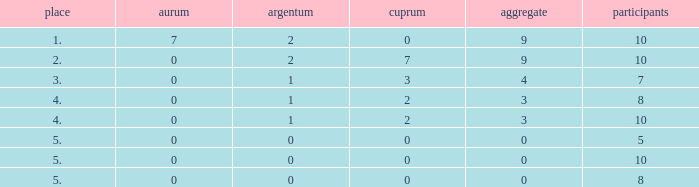What is listed as the highest Participants that also have a Rank of 5, and Silver that's smaller than 0? None. 